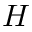Convert formula to latex. <formula><loc_0><loc_0><loc_500><loc_500>H</formula> 